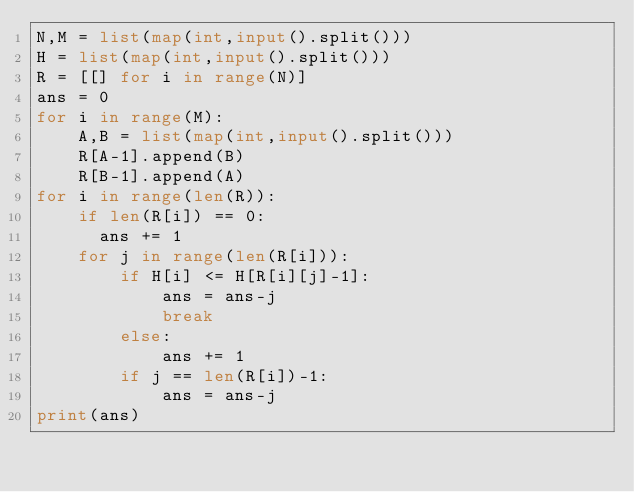Convert code to text. <code><loc_0><loc_0><loc_500><loc_500><_Python_>N,M = list(map(int,input().split()))
H = list(map(int,input().split()))
R = [[] for i in range(N)]
ans = 0
for i in range(M):
    A,B = list(map(int,input().split()))
    R[A-1].append(B)
    R[B-1].append(A)
for i in range(len(R)):
    if len(R[i]) == 0:
      ans += 1
    for j in range(len(R[i])):
        if H[i] <= H[R[i][j]-1]:
            ans = ans-j
            break
        else:
            ans += 1
        if j == len(R[i])-1:
            ans = ans-j
print(ans)</code> 